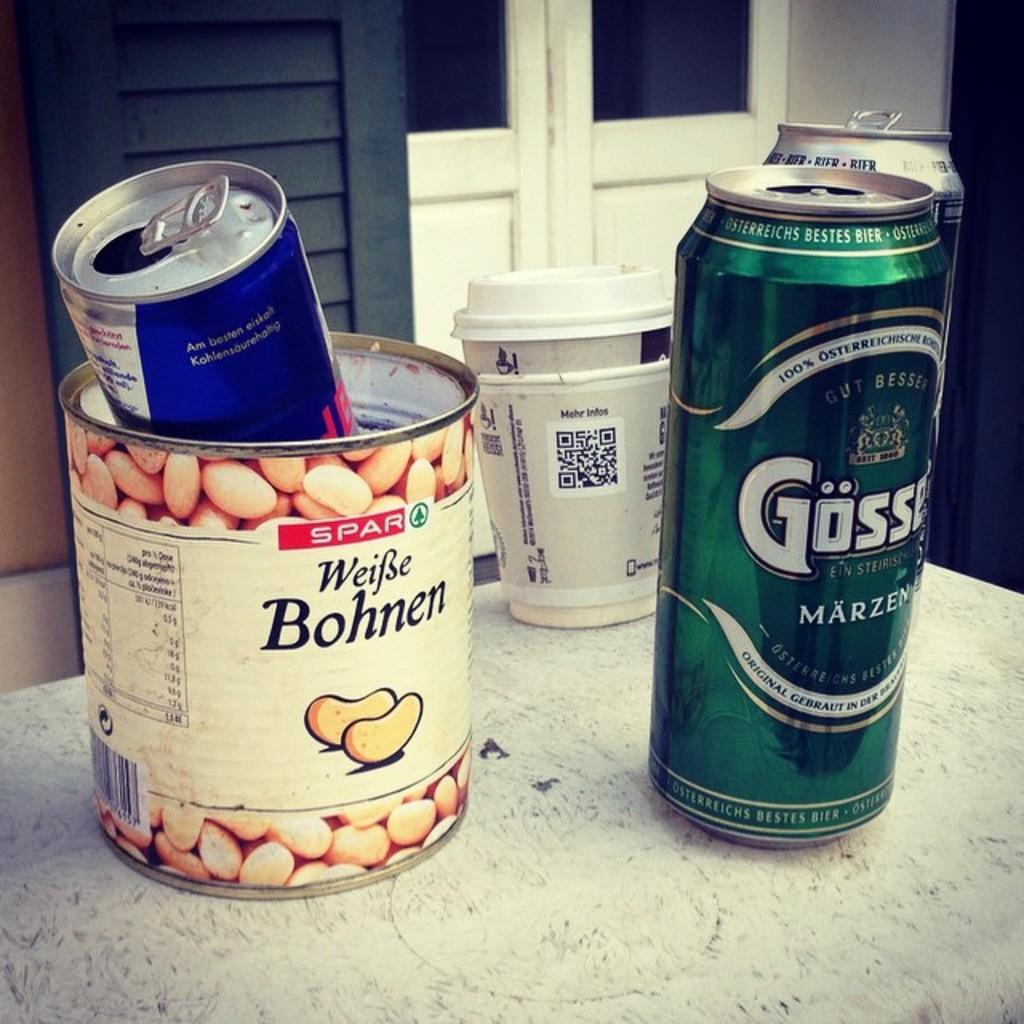<image>
Create a compact narrative representing the image presented. a jar of peanuts with bohnen on it 